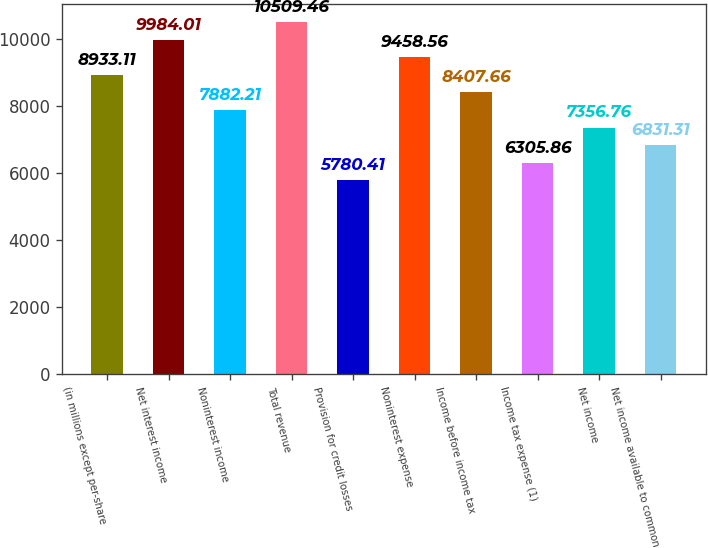Convert chart to OTSL. <chart><loc_0><loc_0><loc_500><loc_500><bar_chart><fcel>(in millions except per-share<fcel>Net interest income<fcel>Noninterest income<fcel>Total revenue<fcel>Provision for credit losses<fcel>Noninterest expense<fcel>Income before income tax<fcel>Income tax expense (1)<fcel>Net income<fcel>Net income available to common<nl><fcel>8933.11<fcel>9984.01<fcel>7882.21<fcel>10509.5<fcel>5780.41<fcel>9458.56<fcel>8407.66<fcel>6305.86<fcel>7356.76<fcel>6831.31<nl></chart> 